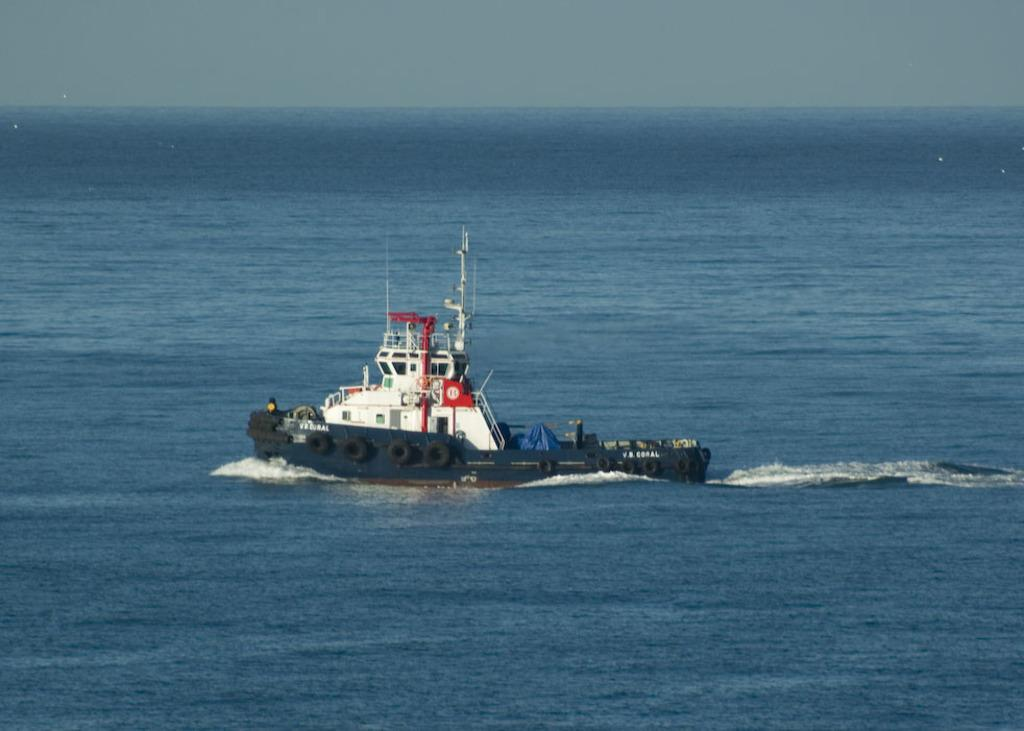What is the main subject in the center of the image? There is a ship in the center of the image. What body of water is the ship located in? The ship is located in a river, which is visible at the bottom of the image. What is visible at the top of the image? The sky is visible at the top of the image. What type of creature can be seen swimming in the river in the image? There is no creature visible in the river in the image. What force is causing the ship to move in the image? The image does not show the ship moving, so it is not possible to determine the force causing it to move. 